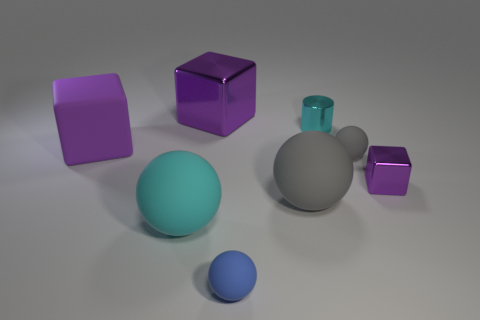Subtract all purple cubes. How many were subtracted if there are1purple cubes left? 2 Subtract 1 balls. How many balls are left? 3 Add 1 small shiny cylinders. How many objects exist? 9 Subtract all cylinders. How many objects are left? 7 Subtract all metallic blocks. Subtract all gray rubber things. How many objects are left? 4 Add 8 large cyan things. How many large cyan things are left? 9 Add 7 purple rubber blocks. How many purple rubber blocks exist? 8 Subtract 0 green balls. How many objects are left? 8 